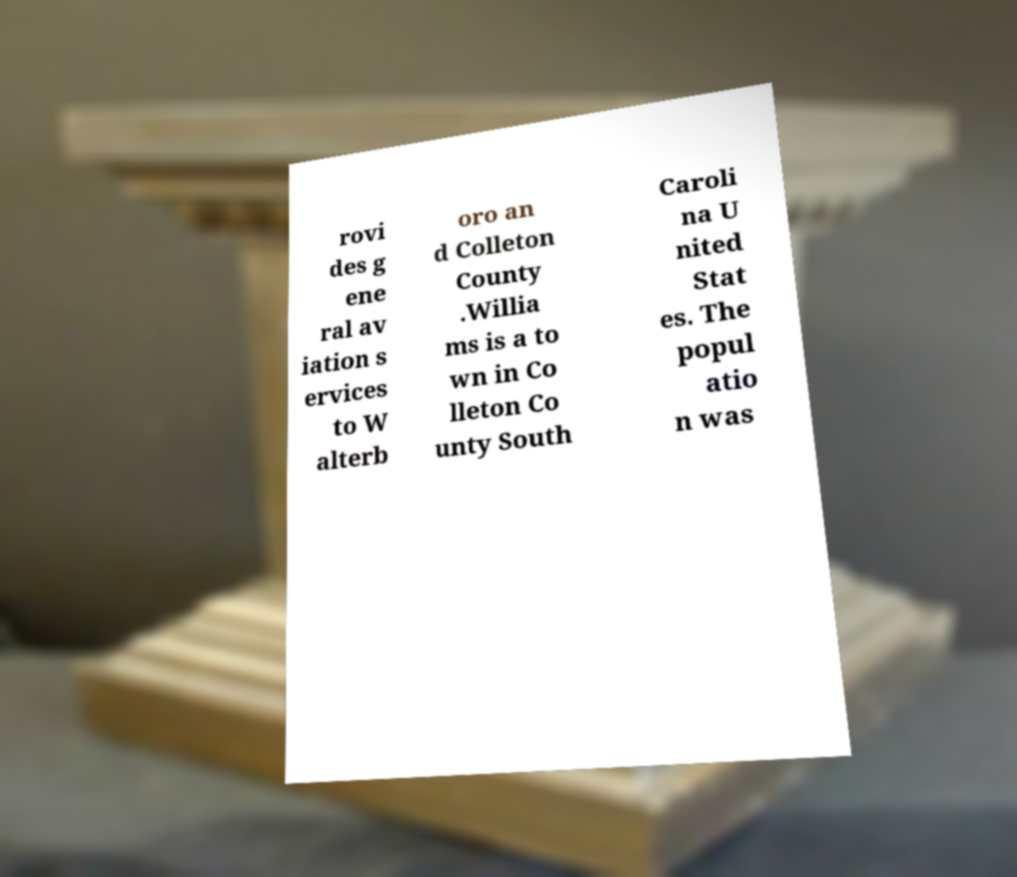Can you read and provide the text displayed in the image?This photo seems to have some interesting text. Can you extract and type it out for me? rovi des g ene ral av iation s ervices to W alterb oro an d Colleton County .Willia ms is a to wn in Co lleton Co unty South Caroli na U nited Stat es. The popul atio n was 